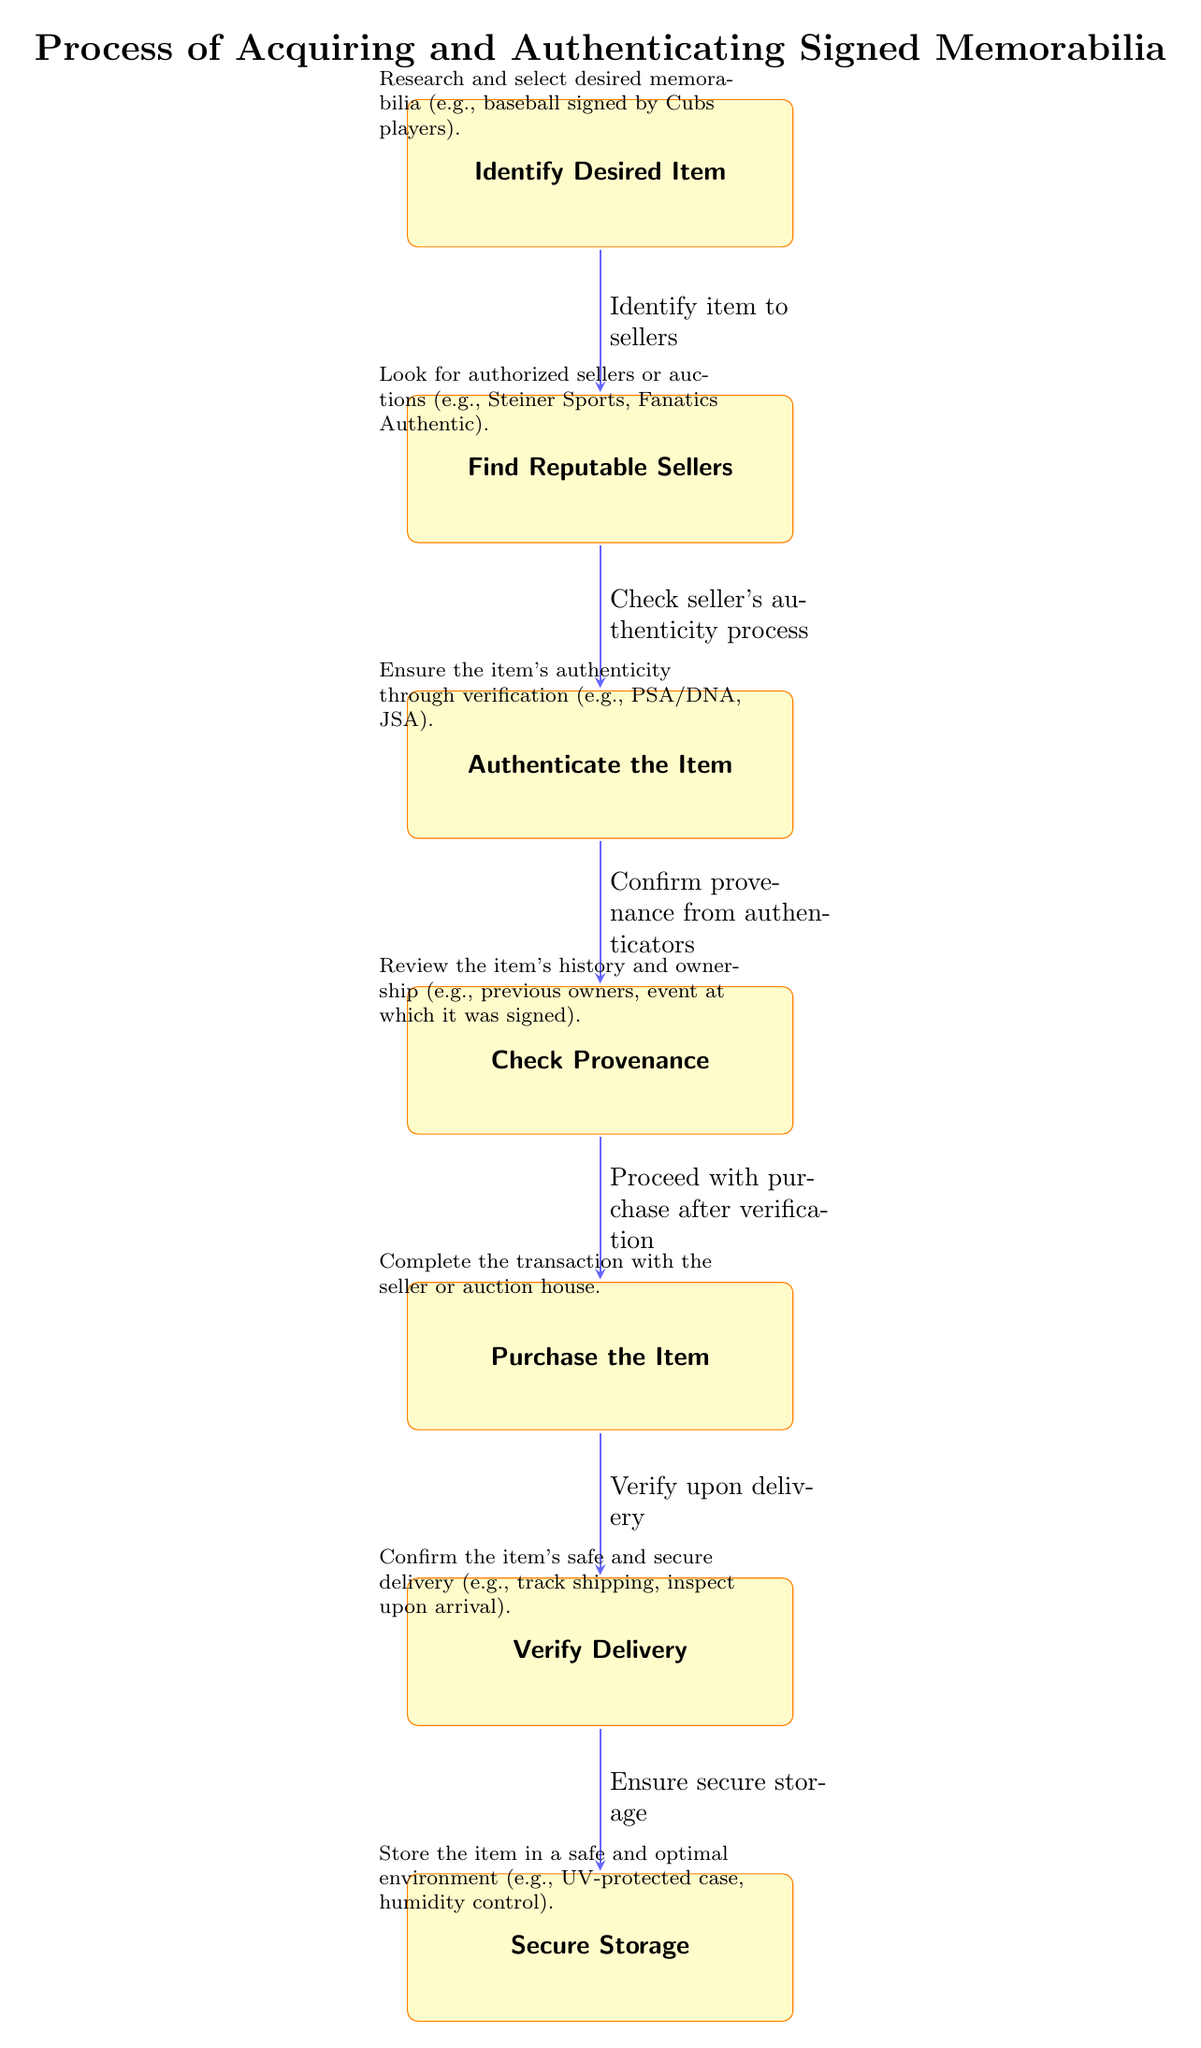What is the first step in acquiring signed memorabilia? The first step is identified as "Identify Desired Item," which is the topmost node in the diagram, indicating it is the starting point of the process.
Answer: Identify Desired Item How many total steps are there in the process? Counting each node in the diagram from "Identify Desired Item" to "Secure Storage," there are seven steps in total.
Answer: 7 What is the last step in the diagram? The last step is "Secure Storage," which is located at the bottom of the diagram, indicating it is the conclusion of the acquisition process.
Answer: Secure Storage What should you verify upon delivery? According to the diagram, you should "Verify upon delivery," which is specified in the sixth step before moving to storage.
Answer: Verify upon delivery What process should be followed after finding reputable sellers? After finding reputable sellers, the next step is to "Authenticate the Item," as indicated by the arrow leading down from that node.
Answer: Authenticate the Item What is required to confirm provenance? The diagram states that to confirm provenance, you should "Confirm provenance from authenticators," specifying the need to engage with recognized authenticators for this verification.
Answer: Confirm provenance from authenticators Why is checking seller's authenticity important? Checking the seller's authenticity is important because it ensures you are dealing with a reputable source, according to the flow from finding sellers to authenticating items.
Answer: To ensure you are dealing with a reputable source What do you do after checking provenance? After checking provenance, the next action is to "Purchase the Item," a step that logically follows the verification process before the transaction.
Answer: Purchase the Item What should be done about the item's history? The item's history should be reviewed, as indicated by the step "Check Provenance," which emphasizes understanding the ownership and previous events related to the memorabilia.
Answer: Review the item's history 